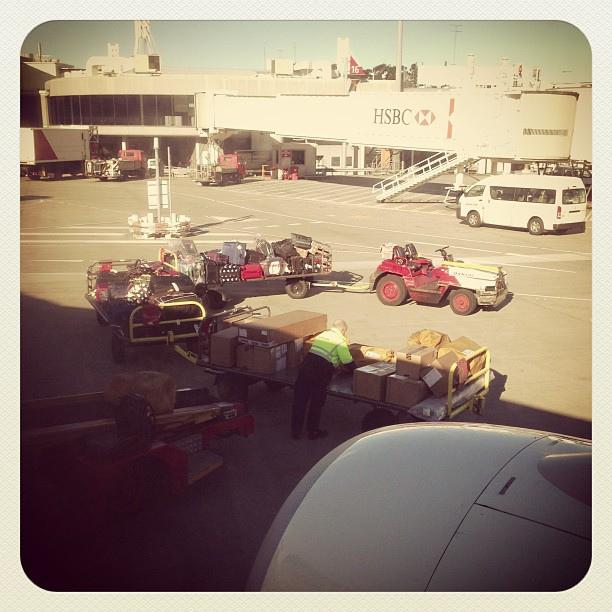What is cast?
Be succinct. Shadow. What letters are on the building?
Keep it brief. Hsbc. Are these vehicles parked?
Give a very brief answer. Yes. Where was this likely taken at?
Keep it brief. Airport. 